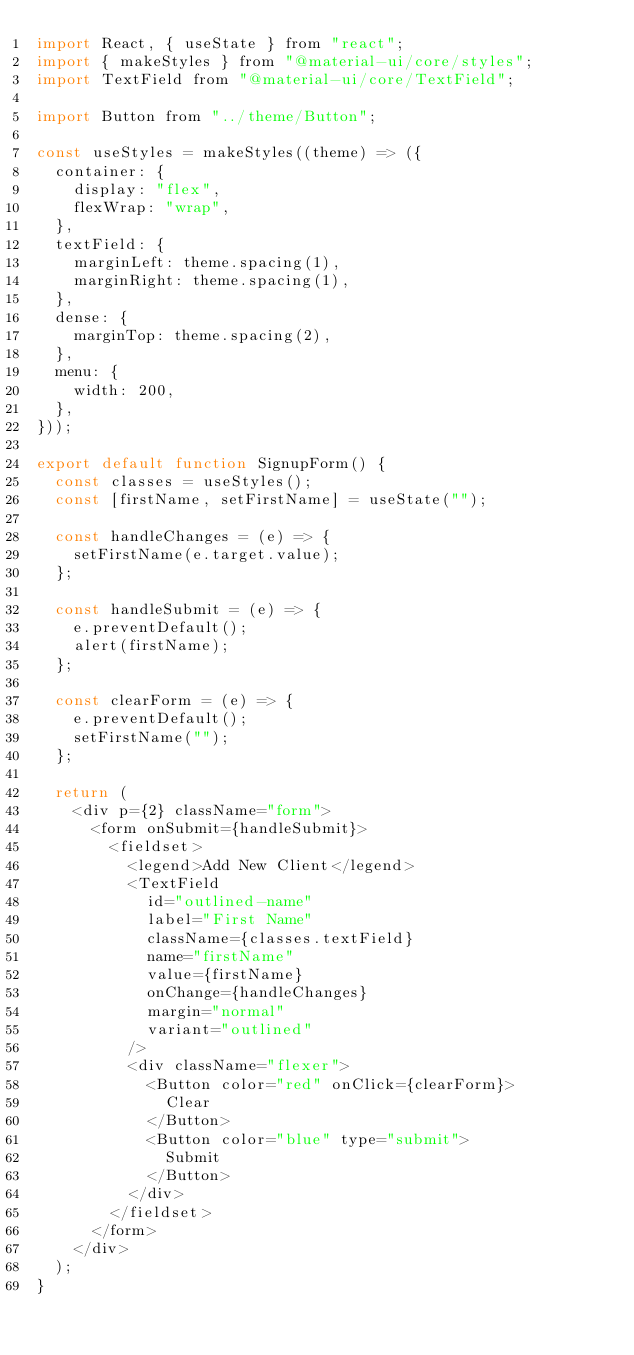<code> <loc_0><loc_0><loc_500><loc_500><_JavaScript_>import React, { useState } from "react";
import { makeStyles } from "@material-ui/core/styles";
import TextField from "@material-ui/core/TextField";

import Button from "../theme/Button";

const useStyles = makeStyles((theme) => ({
  container: {
    display: "flex",
    flexWrap: "wrap",
  },
  textField: {
    marginLeft: theme.spacing(1),
    marginRight: theme.spacing(1),
  },
  dense: {
    marginTop: theme.spacing(2),
  },
  menu: {
    width: 200,
  },
}));

export default function SignupForm() {
  const classes = useStyles();
  const [firstName, setFirstName] = useState("");

  const handleChanges = (e) => {
    setFirstName(e.target.value);
  };

  const handleSubmit = (e) => {
    e.preventDefault();
    alert(firstName);
  };

  const clearForm = (e) => {
    e.preventDefault();
    setFirstName("");
  };

  return (
    <div p={2} className="form">
      <form onSubmit={handleSubmit}>
        <fieldset>
          <legend>Add New Client</legend>
          <TextField
            id="outlined-name"
            label="First Name"
            className={classes.textField}
            name="firstName"
            value={firstName}
            onChange={handleChanges}
            margin="normal"
            variant="outlined"
          />
          <div className="flexer">
            <Button color="red" onClick={clearForm}>
              Clear
            </Button>
            <Button color="blue" type="submit">
              Submit
            </Button>
          </div>
        </fieldset>
      </form>
    </div>
  );
}
</code> 